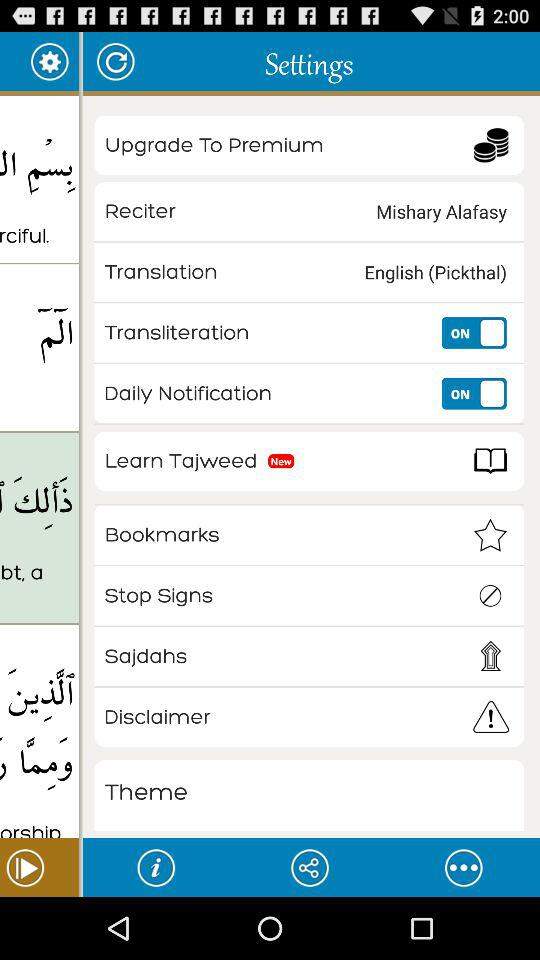What is the status of "Daily notification"? The status is "on". 